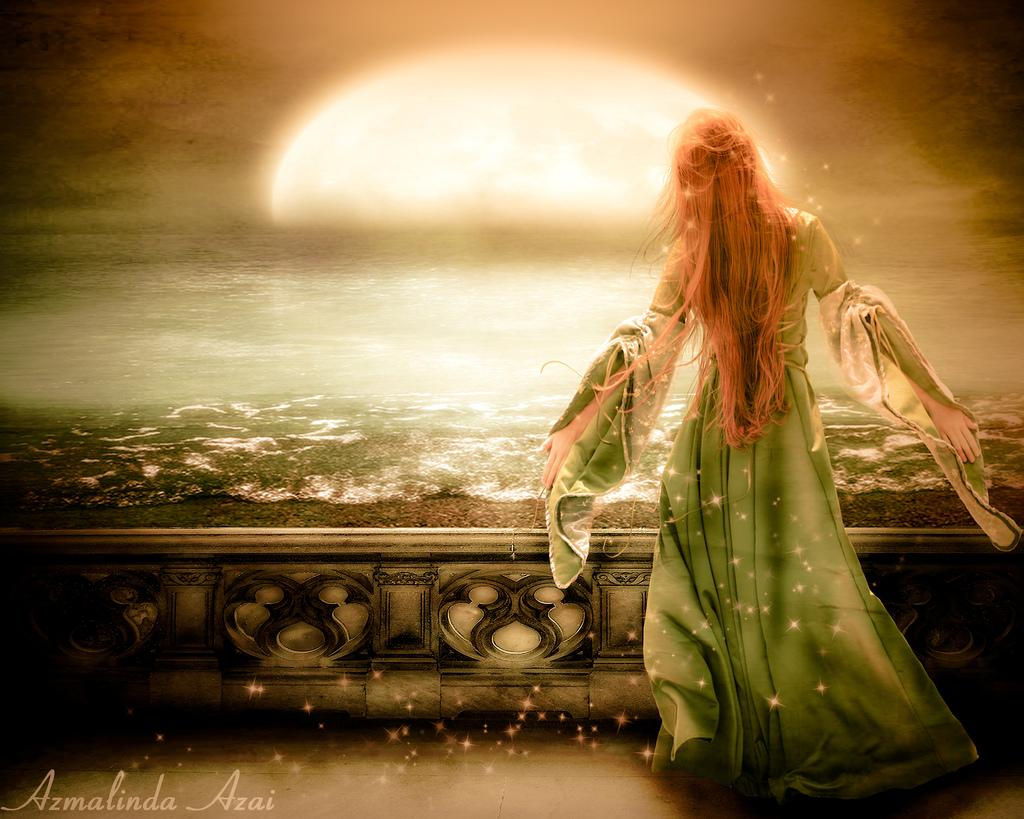What type of image is being described? The image is animated. What can be seen on the ground in the image? There is ground visible in the image. Who is present in the image? There is a lady in the image. Where is the text located in the image? The text is in the bottom left corner of the image. What type of bottle is being used in the war scene depicted in the image? There is no war scene or bottle present in the image; it features an animated lady and text in the bottom left corner. 